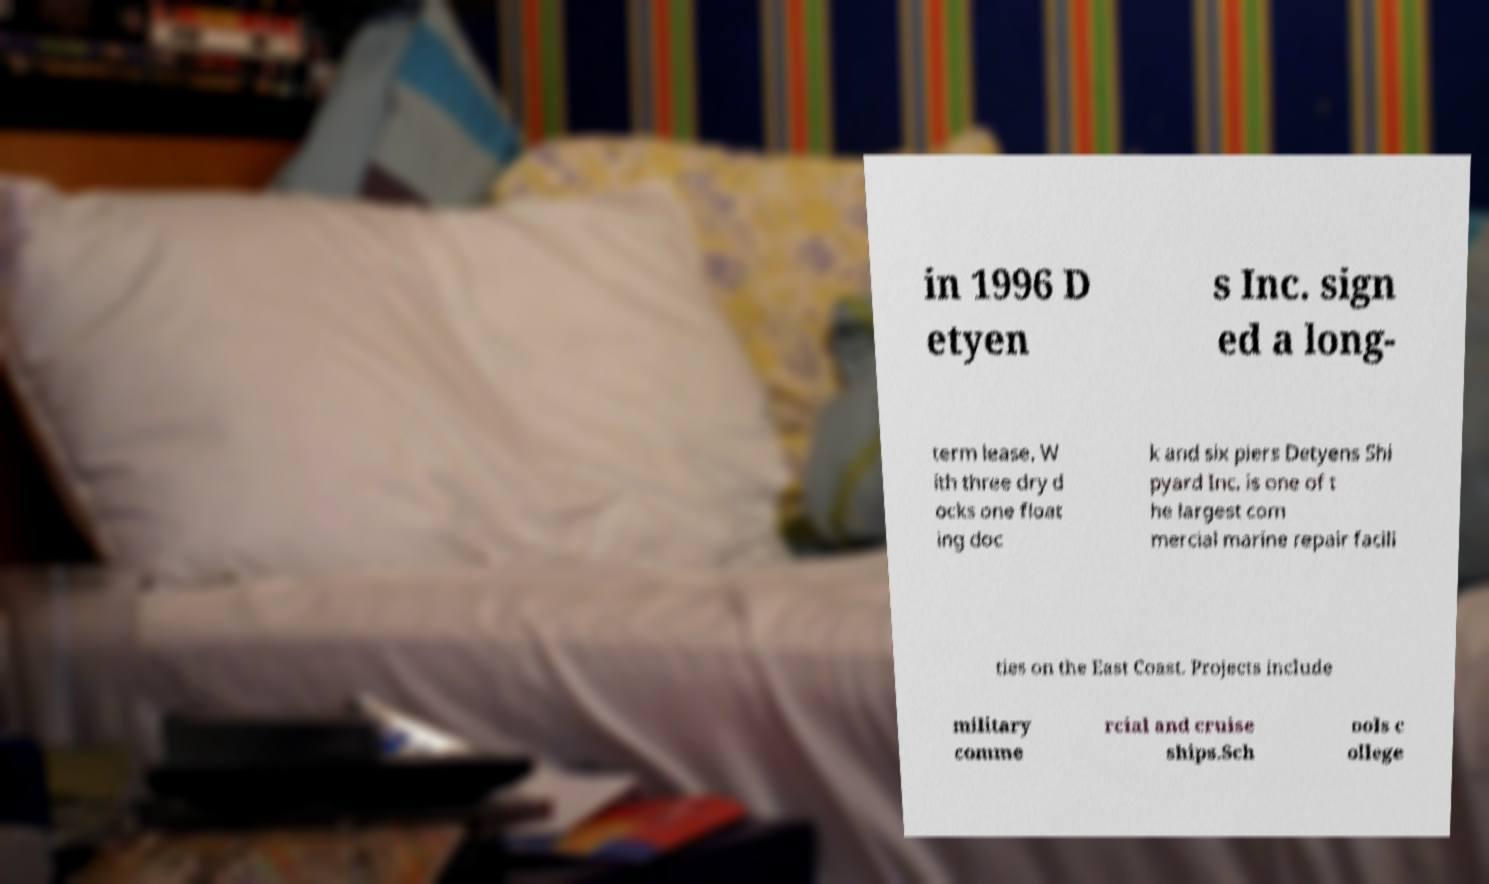Please identify and transcribe the text found in this image. in 1996 D etyen s Inc. sign ed a long- term lease. W ith three dry d ocks one float ing doc k and six piers Detyens Shi pyard Inc. is one of t he largest com mercial marine repair facili ties on the East Coast. Projects include military comme rcial and cruise ships.Sch ools c ollege 